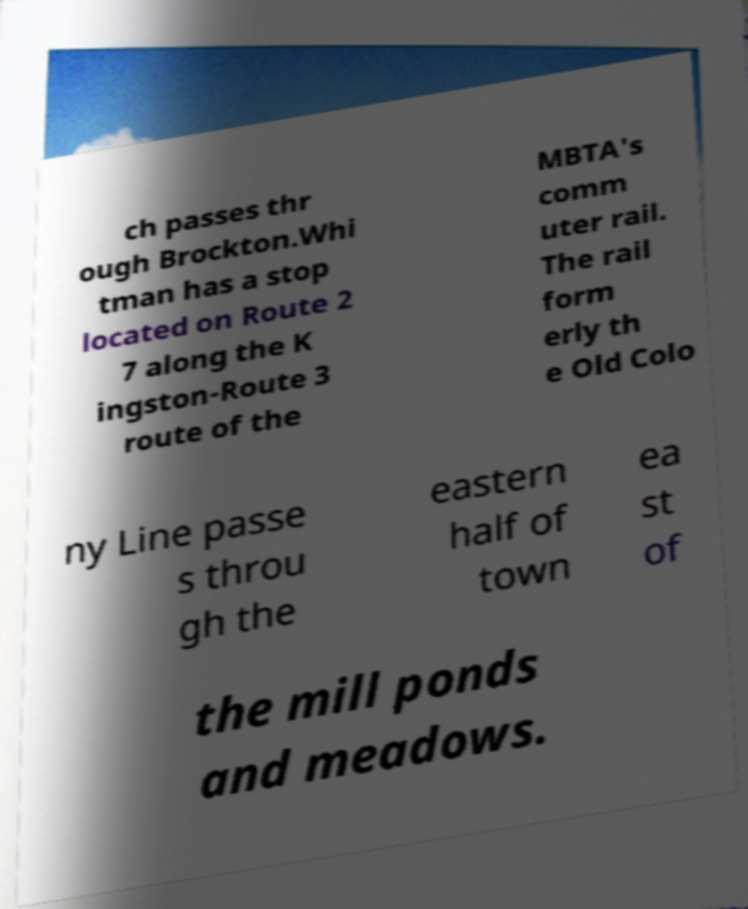Could you extract and type out the text from this image? ch passes thr ough Brockton.Whi tman has a stop located on Route 2 7 along the K ingston-Route 3 route of the MBTA's comm uter rail. The rail form erly th e Old Colo ny Line passe s throu gh the eastern half of town ea st of the mill ponds and meadows. 